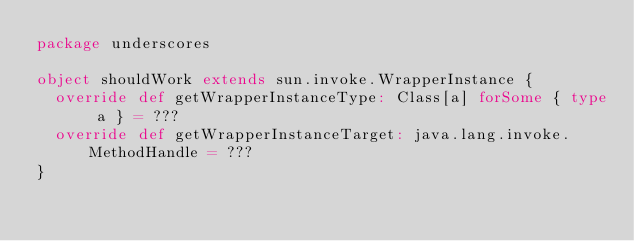<code> <loc_0><loc_0><loc_500><loc_500><_Scala_>package underscores

object shouldWork extends sun.invoke.WrapperInstance {
  override def getWrapperInstanceType: Class[a] forSome { type a } = ???
  override def getWrapperInstanceTarget: java.lang.invoke.MethodHandle = ???
}
</code> 